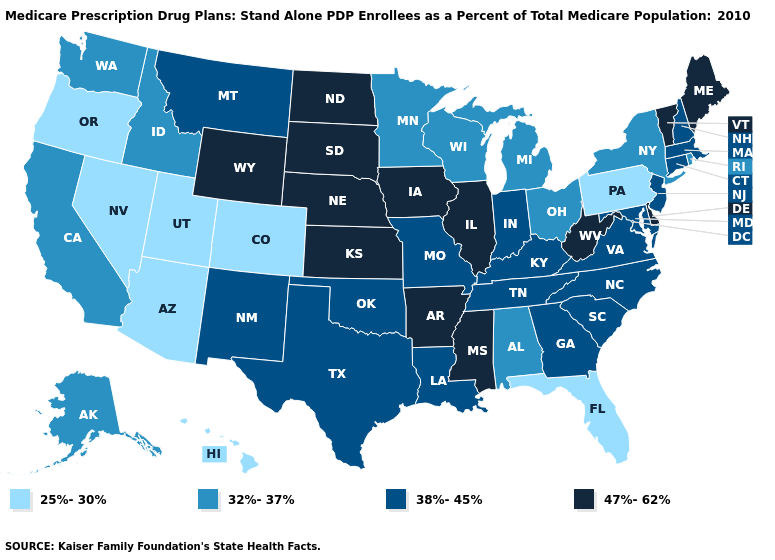What is the lowest value in the USA?
Write a very short answer. 25%-30%. What is the value of Illinois?
Give a very brief answer. 47%-62%. What is the value of Tennessee?
Quick response, please. 38%-45%. Which states have the lowest value in the Northeast?
Concise answer only. Pennsylvania. Name the states that have a value in the range 47%-62%?
Quick response, please. Arkansas, Delaware, Iowa, Illinois, Kansas, Maine, Mississippi, North Dakota, Nebraska, South Dakota, Vermont, West Virginia, Wyoming. Among the states that border Wyoming , which have the highest value?
Concise answer only. Nebraska, South Dakota. What is the value of South Carolina?
Be succinct. 38%-45%. What is the value of Vermont?
Be succinct. 47%-62%. Among the states that border Nebraska , which have the lowest value?
Be succinct. Colorado. Name the states that have a value in the range 32%-37%?
Concise answer only. Alaska, Alabama, California, Idaho, Michigan, Minnesota, New York, Ohio, Rhode Island, Washington, Wisconsin. Name the states that have a value in the range 32%-37%?
Give a very brief answer. Alaska, Alabama, California, Idaho, Michigan, Minnesota, New York, Ohio, Rhode Island, Washington, Wisconsin. Among the states that border Louisiana , which have the lowest value?
Concise answer only. Texas. Name the states that have a value in the range 38%-45%?
Short answer required. Connecticut, Georgia, Indiana, Kentucky, Louisiana, Massachusetts, Maryland, Missouri, Montana, North Carolina, New Hampshire, New Jersey, New Mexico, Oklahoma, South Carolina, Tennessee, Texas, Virginia. What is the lowest value in the West?
Short answer required. 25%-30%. Does Washington have a higher value than Rhode Island?
Concise answer only. No. 